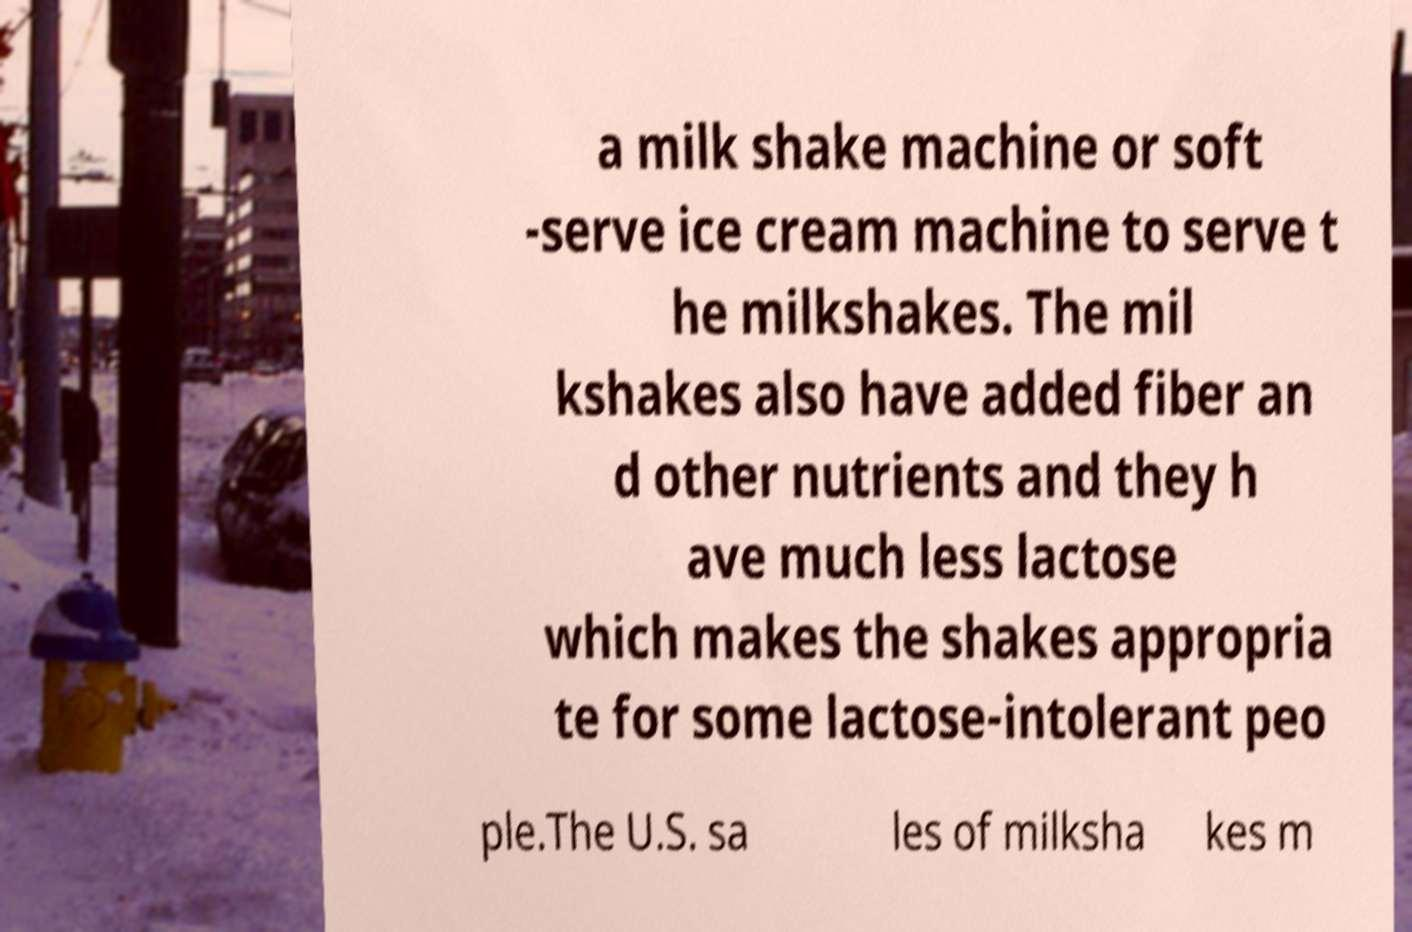I need the written content from this picture converted into text. Can you do that? a milk shake machine or soft -serve ice cream machine to serve t he milkshakes. The mil kshakes also have added fiber an d other nutrients and they h ave much less lactose which makes the shakes appropria te for some lactose-intolerant peo ple.The U.S. sa les of milksha kes m 